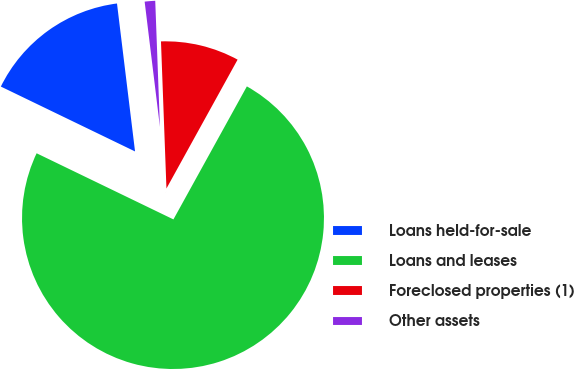Convert chart to OTSL. <chart><loc_0><loc_0><loc_500><loc_500><pie_chart><fcel>Loans held-for-sale<fcel>Loans and leases<fcel>Foreclosed properties (1)<fcel>Other assets<nl><fcel>15.9%<fcel>74.13%<fcel>8.62%<fcel>1.34%<nl></chart> 